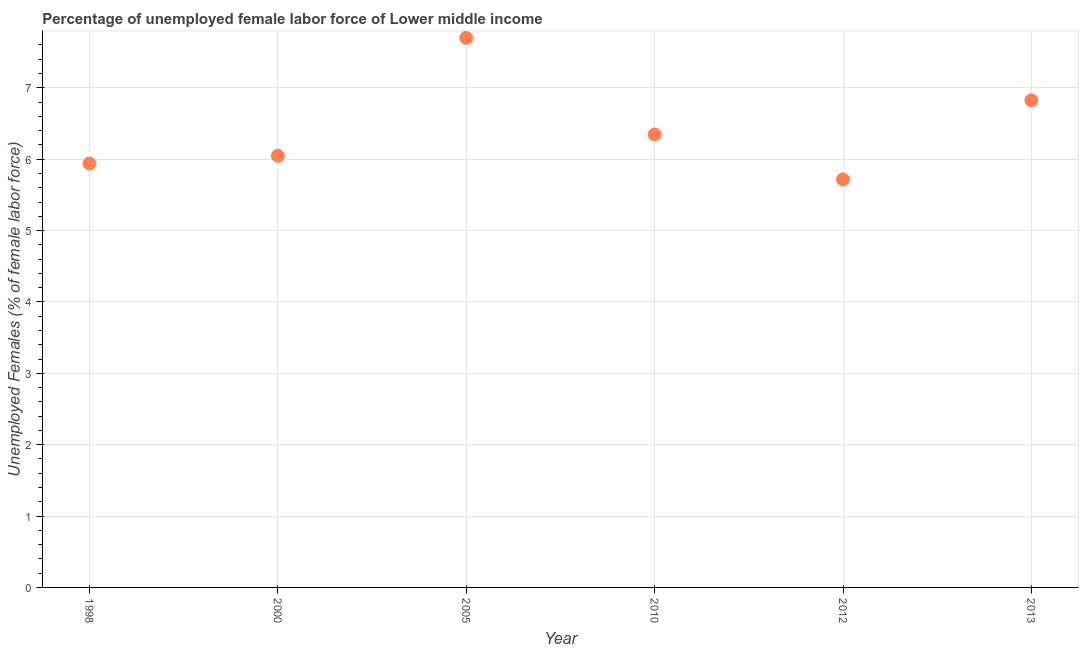What is the total unemployed female labour force in 2000?
Your response must be concise. 6.05. Across all years, what is the maximum total unemployed female labour force?
Keep it short and to the point. 7.7. Across all years, what is the minimum total unemployed female labour force?
Your answer should be very brief. 5.72. What is the sum of the total unemployed female labour force?
Provide a succinct answer. 38.57. What is the difference between the total unemployed female labour force in 2010 and 2013?
Ensure brevity in your answer.  -0.48. What is the average total unemployed female labour force per year?
Make the answer very short. 6.43. What is the median total unemployed female labour force?
Offer a terse response. 6.2. In how many years, is the total unemployed female labour force greater than 3.2 %?
Offer a very short reply. 6. Do a majority of the years between 2005 and 2010 (inclusive) have total unemployed female labour force greater than 4 %?
Provide a succinct answer. Yes. What is the ratio of the total unemployed female labour force in 1998 to that in 2005?
Make the answer very short. 0.77. Is the difference between the total unemployed female labour force in 1998 and 2013 greater than the difference between any two years?
Your response must be concise. No. What is the difference between the highest and the second highest total unemployed female labour force?
Keep it short and to the point. 0.88. Is the sum of the total unemployed female labour force in 1998 and 2000 greater than the maximum total unemployed female labour force across all years?
Make the answer very short. Yes. What is the difference between the highest and the lowest total unemployed female labour force?
Your answer should be very brief. 1.98. Does the total unemployed female labour force monotonically increase over the years?
Provide a short and direct response. No. What is the title of the graph?
Provide a short and direct response. Percentage of unemployed female labor force of Lower middle income. What is the label or title of the Y-axis?
Make the answer very short. Unemployed Females (% of female labor force). What is the Unemployed Females (% of female labor force) in 1998?
Provide a short and direct response. 5.94. What is the Unemployed Females (% of female labor force) in 2000?
Your response must be concise. 6.05. What is the Unemployed Females (% of female labor force) in 2005?
Your answer should be compact. 7.7. What is the Unemployed Females (% of female labor force) in 2010?
Provide a short and direct response. 6.35. What is the Unemployed Females (% of female labor force) in 2012?
Offer a very short reply. 5.72. What is the Unemployed Females (% of female labor force) in 2013?
Provide a short and direct response. 6.82. What is the difference between the Unemployed Females (% of female labor force) in 1998 and 2000?
Your answer should be compact. -0.11. What is the difference between the Unemployed Females (% of female labor force) in 1998 and 2005?
Offer a very short reply. -1.76. What is the difference between the Unemployed Females (% of female labor force) in 1998 and 2010?
Your response must be concise. -0.41. What is the difference between the Unemployed Females (% of female labor force) in 1998 and 2012?
Offer a terse response. 0.22. What is the difference between the Unemployed Females (% of female labor force) in 1998 and 2013?
Offer a terse response. -0.89. What is the difference between the Unemployed Females (% of female labor force) in 2000 and 2005?
Offer a very short reply. -1.65. What is the difference between the Unemployed Females (% of female labor force) in 2000 and 2010?
Offer a very short reply. -0.3. What is the difference between the Unemployed Females (% of female labor force) in 2000 and 2012?
Keep it short and to the point. 0.33. What is the difference between the Unemployed Females (% of female labor force) in 2000 and 2013?
Provide a short and direct response. -0.77. What is the difference between the Unemployed Females (% of female labor force) in 2005 and 2010?
Give a very brief answer. 1.35. What is the difference between the Unemployed Females (% of female labor force) in 2005 and 2012?
Your answer should be compact. 1.98. What is the difference between the Unemployed Females (% of female labor force) in 2005 and 2013?
Offer a terse response. 0.88. What is the difference between the Unemployed Females (% of female labor force) in 2010 and 2012?
Keep it short and to the point. 0.63. What is the difference between the Unemployed Females (% of female labor force) in 2010 and 2013?
Provide a short and direct response. -0.48. What is the difference between the Unemployed Females (% of female labor force) in 2012 and 2013?
Your response must be concise. -1.11. What is the ratio of the Unemployed Females (% of female labor force) in 1998 to that in 2005?
Give a very brief answer. 0.77. What is the ratio of the Unemployed Females (% of female labor force) in 1998 to that in 2010?
Ensure brevity in your answer.  0.94. What is the ratio of the Unemployed Females (% of female labor force) in 1998 to that in 2012?
Your answer should be very brief. 1.04. What is the ratio of the Unemployed Females (% of female labor force) in 1998 to that in 2013?
Provide a succinct answer. 0.87. What is the ratio of the Unemployed Females (% of female labor force) in 2000 to that in 2005?
Your answer should be compact. 0.79. What is the ratio of the Unemployed Females (% of female labor force) in 2000 to that in 2010?
Give a very brief answer. 0.95. What is the ratio of the Unemployed Females (% of female labor force) in 2000 to that in 2012?
Your answer should be very brief. 1.06. What is the ratio of the Unemployed Females (% of female labor force) in 2000 to that in 2013?
Offer a very short reply. 0.89. What is the ratio of the Unemployed Females (% of female labor force) in 2005 to that in 2010?
Your response must be concise. 1.21. What is the ratio of the Unemployed Females (% of female labor force) in 2005 to that in 2012?
Provide a short and direct response. 1.35. What is the ratio of the Unemployed Females (% of female labor force) in 2005 to that in 2013?
Your answer should be compact. 1.13. What is the ratio of the Unemployed Females (% of female labor force) in 2010 to that in 2012?
Your answer should be compact. 1.11. What is the ratio of the Unemployed Females (% of female labor force) in 2010 to that in 2013?
Provide a short and direct response. 0.93. What is the ratio of the Unemployed Females (% of female labor force) in 2012 to that in 2013?
Provide a short and direct response. 0.84. 